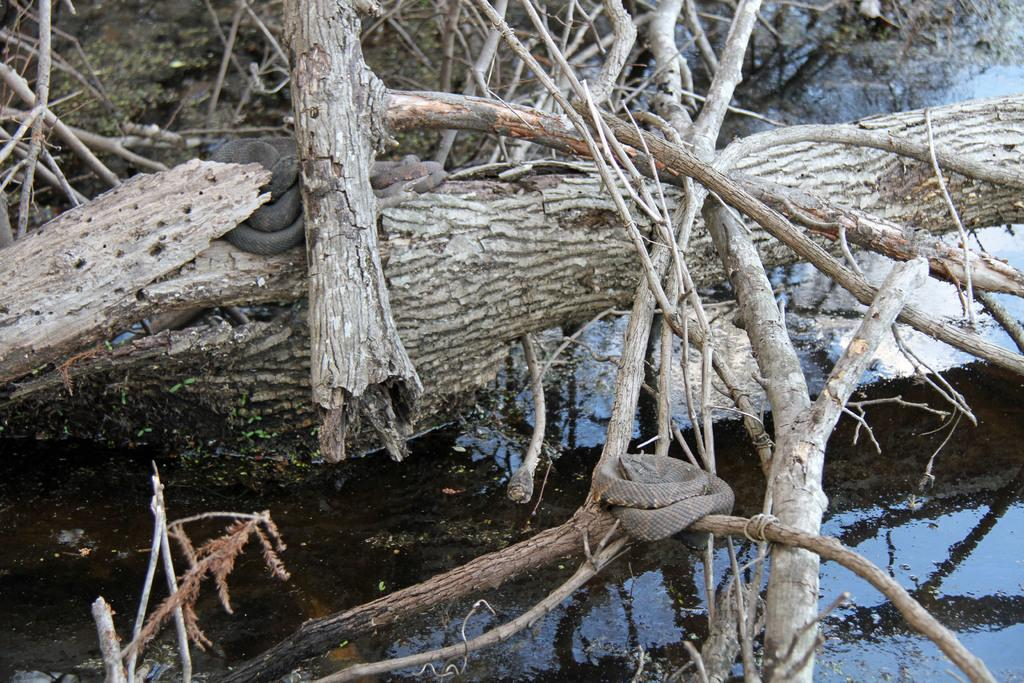What type of vegetation can be seen in the image? There are branches of trees in the image. What creatures are present on the branches? There are snakes on the branches in the image. What natural element is visible in the image? There is water visible in the image. How does the honey attract the snakes in the image? There is no honey present in the image, and therefore no attraction can be observed. 